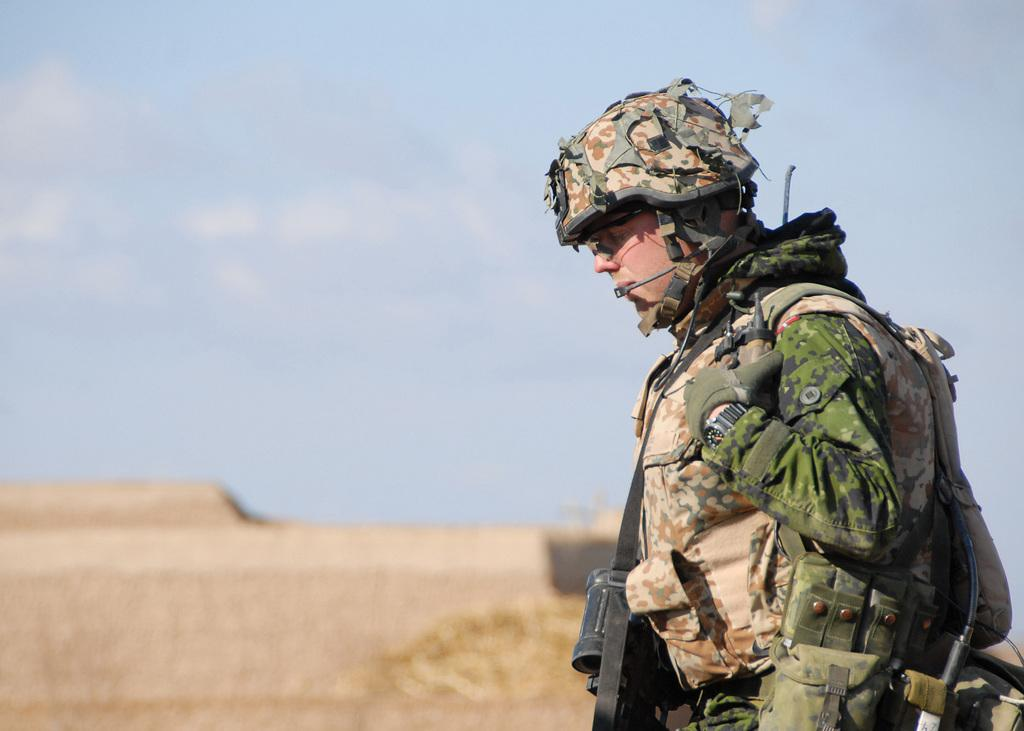What is the man in the image doing? The man is standing in the image. What is the man carrying in the image? The man is carrying a bag. What protective gear is the man wearing in the image? The man is wearing a helmet and gloves. What can be seen in the background of the image? The background of the image is blurry, and the sky is visible. What type of mask is the lawyer wearing in the image? There is no lawyer or mask present in the image. How many flies can be seen buzzing around the man in the image? There are no flies present in the image. 